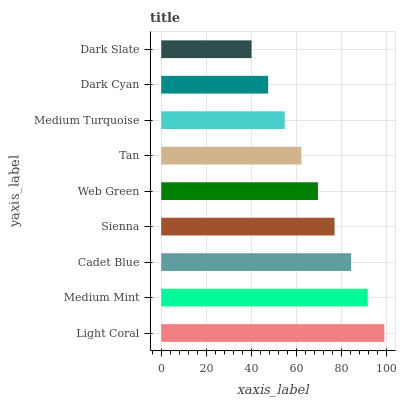Is Dark Slate the minimum?
Answer yes or no. Yes. Is Light Coral the maximum?
Answer yes or no. Yes. Is Medium Mint the minimum?
Answer yes or no. No. Is Medium Mint the maximum?
Answer yes or no. No. Is Light Coral greater than Medium Mint?
Answer yes or no. Yes. Is Medium Mint less than Light Coral?
Answer yes or no. Yes. Is Medium Mint greater than Light Coral?
Answer yes or no. No. Is Light Coral less than Medium Mint?
Answer yes or no. No. Is Web Green the high median?
Answer yes or no. Yes. Is Web Green the low median?
Answer yes or no. Yes. Is Light Coral the high median?
Answer yes or no. No. Is Cadet Blue the low median?
Answer yes or no. No. 